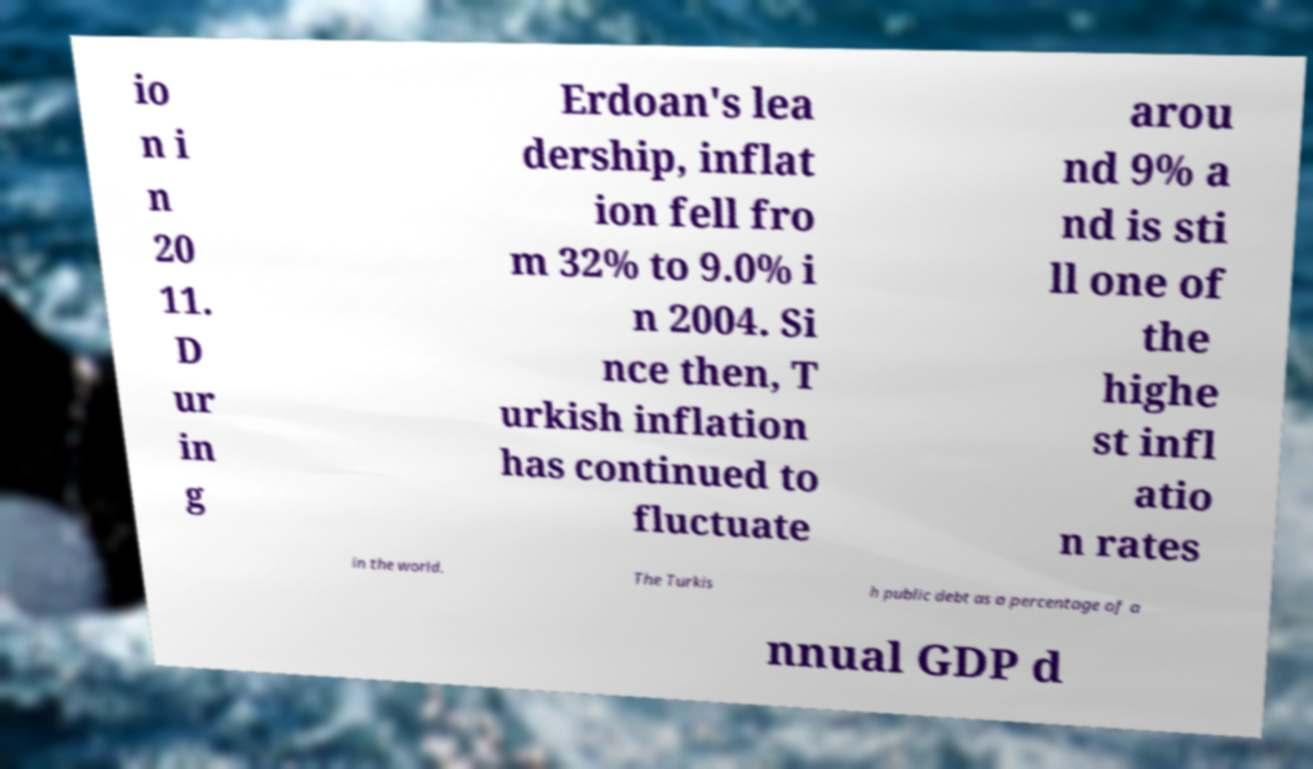Could you assist in decoding the text presented in this image and type it out clearly? io n i n 20 11. D ur in g Erdoan's lea dership, inflat ion fell fro m 32% to 9.0% i n 2004. Si nce then, T urkish inflation has continued to fluctuate arou nd 9% a nd is sti ll one of the highe st infl atio n rates in the world. The Turkis h public debt as a percentage of a nnual GDP d 